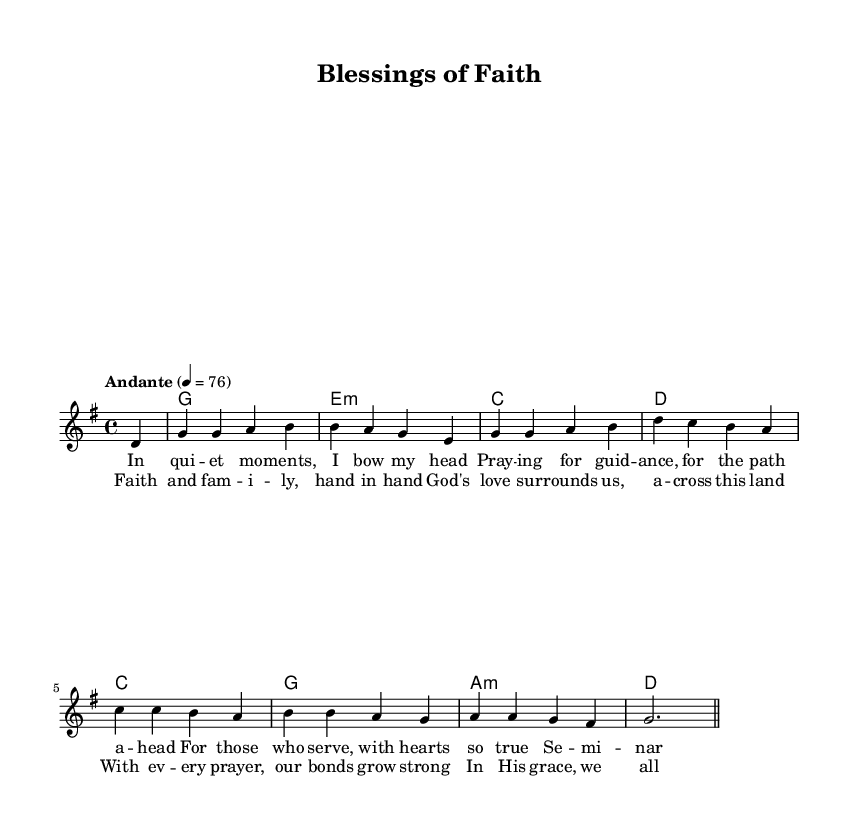what is the key signature of this music? The key signature is G major, which has one sharp (F#). This is determined by looking at the presence of one sharp in the key signature indicated at the beginning of the sheet music.
Answer: G major what is the time signature of this music? The time signature is 4/4, as indicated at the beginning of the sheet music, denoting four beats in each measure.
Answer: 4/4 what is the tempo marking of this music? The tempo marking is Andante, which is a moderate pace. This can be found in the tempo marking section written above the staff.
Answer: Andante how many verses are in the song? There is one verse in the song, as only the lyrics for verse one are provided before the chorus.
Answer: One what is the first note of the melody? The first note of the melody is D, which is the first note that appears in the melody line after the initial partial measure.
Answer: D what chords accompany the first measure? The chord that accompanies the first measure is G, as indicated in the chord mode above the melody.
Answer: G how does the chorus relate to the verse in structure? The chorus follows the verse musically and lyrically, usually repeating themes from the verse, thus enhancing the lyrical message about faith and family. This is typical in pop ballad structure.
Answer: Returns to similar themes 